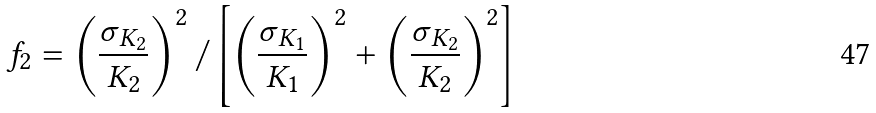<formula> <loc_0><loc_0><loc_500><loc_500>f _ { 2 } = \left ( \frac { \sigma _ { K _ { 2 } } } { K _ { 2 } } \right ) ^ { 2 } / \left [ \left ( \frac { \sigma _ { K _ { 1 } } } { K _ { 1 } } \right ) ^ { 2 } + \left ( \frac { \sigma _ { K _ { 2 } } } { K _ { 2 } } \right ) ^ { 2 } \right ]</formula> 